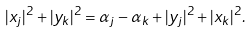Convert formula to latex. <formula><loc_0><loc_0><loc_500><loc_500>| x _ { j } | ^ { 2 } + | y _ { k } | ^ { 2 } = \alpha _ { j } - \alpha _ { k } + | y _ { j } | ^ { 2 } + | x _ { k } | ^ { 2 } .</formula> 